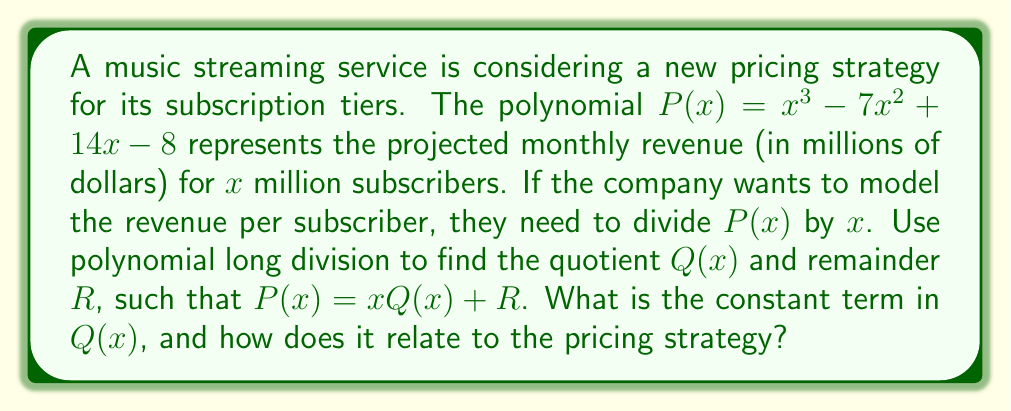Can you answer this question? Let's perform polynomial long division of $P(x)$ by $x$:

$$\begin{array}{r}
x^2 - 7x + 14 \\
x \enclose{longdiv}{x^3 - 7x^2 + 14x - 8} \\
\underline{x^3 \phantom{- 7x^2 + 14x - 8}} \\
-7x^2 + 14x - 8 \\
\underline{-7x^2 \phantom{+ 14x - 8}} \\
14x - 8 \\
\underline{14x \phantom{- 8}} \\
-8
\end{array}$$

From this division, we can see that:
$Q(x) = x^2 - 7x + 14$
$R = -8$

Therefore, $P(x) = x(x^2 - 7x + 14) - 8$

The constant term in $Q(x)$ is 14. In the context of the pricing strategy, this represents the base price per subscriber (in dollars) when the number of subscribers is very large. The remainder of -8 million dollars represents a fixed cost or initial investment that is independent of the number of subscribers.
Answer: 14; base price per subscriber for large subscriber base 